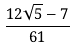Convert formula to latex. <formula><loc_0><loc_0><loc_500><loc_500>\frac { 1 2 \sqrt { 5 } - 7 } { 6 1 }</formula> 